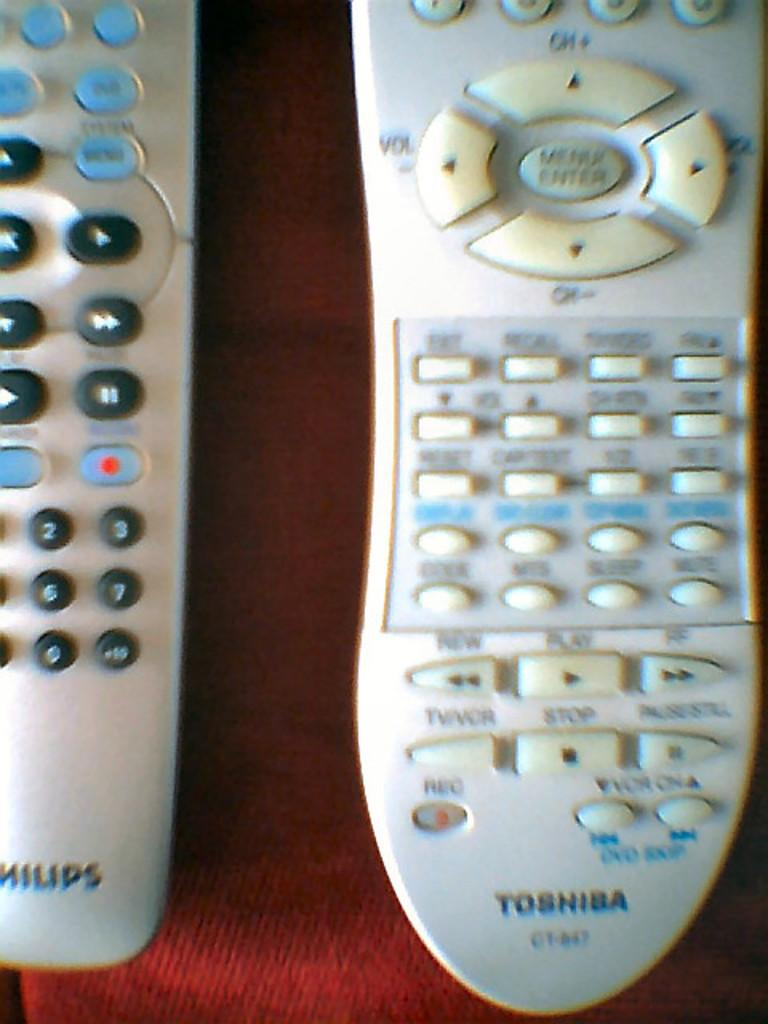<image>
Give a short and clear explanation of the subsequent image. A Philips and Toshiba white remote beside each other. 